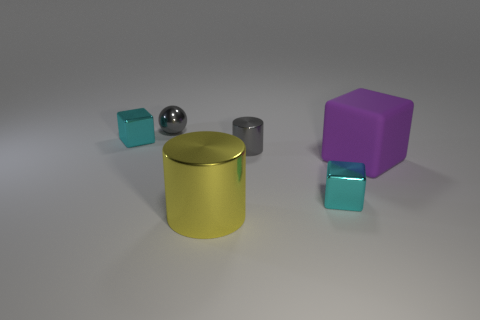What number of tiny cyan objects are on the right side of the gray cylinder that is behind the big purple rubber object? 1 